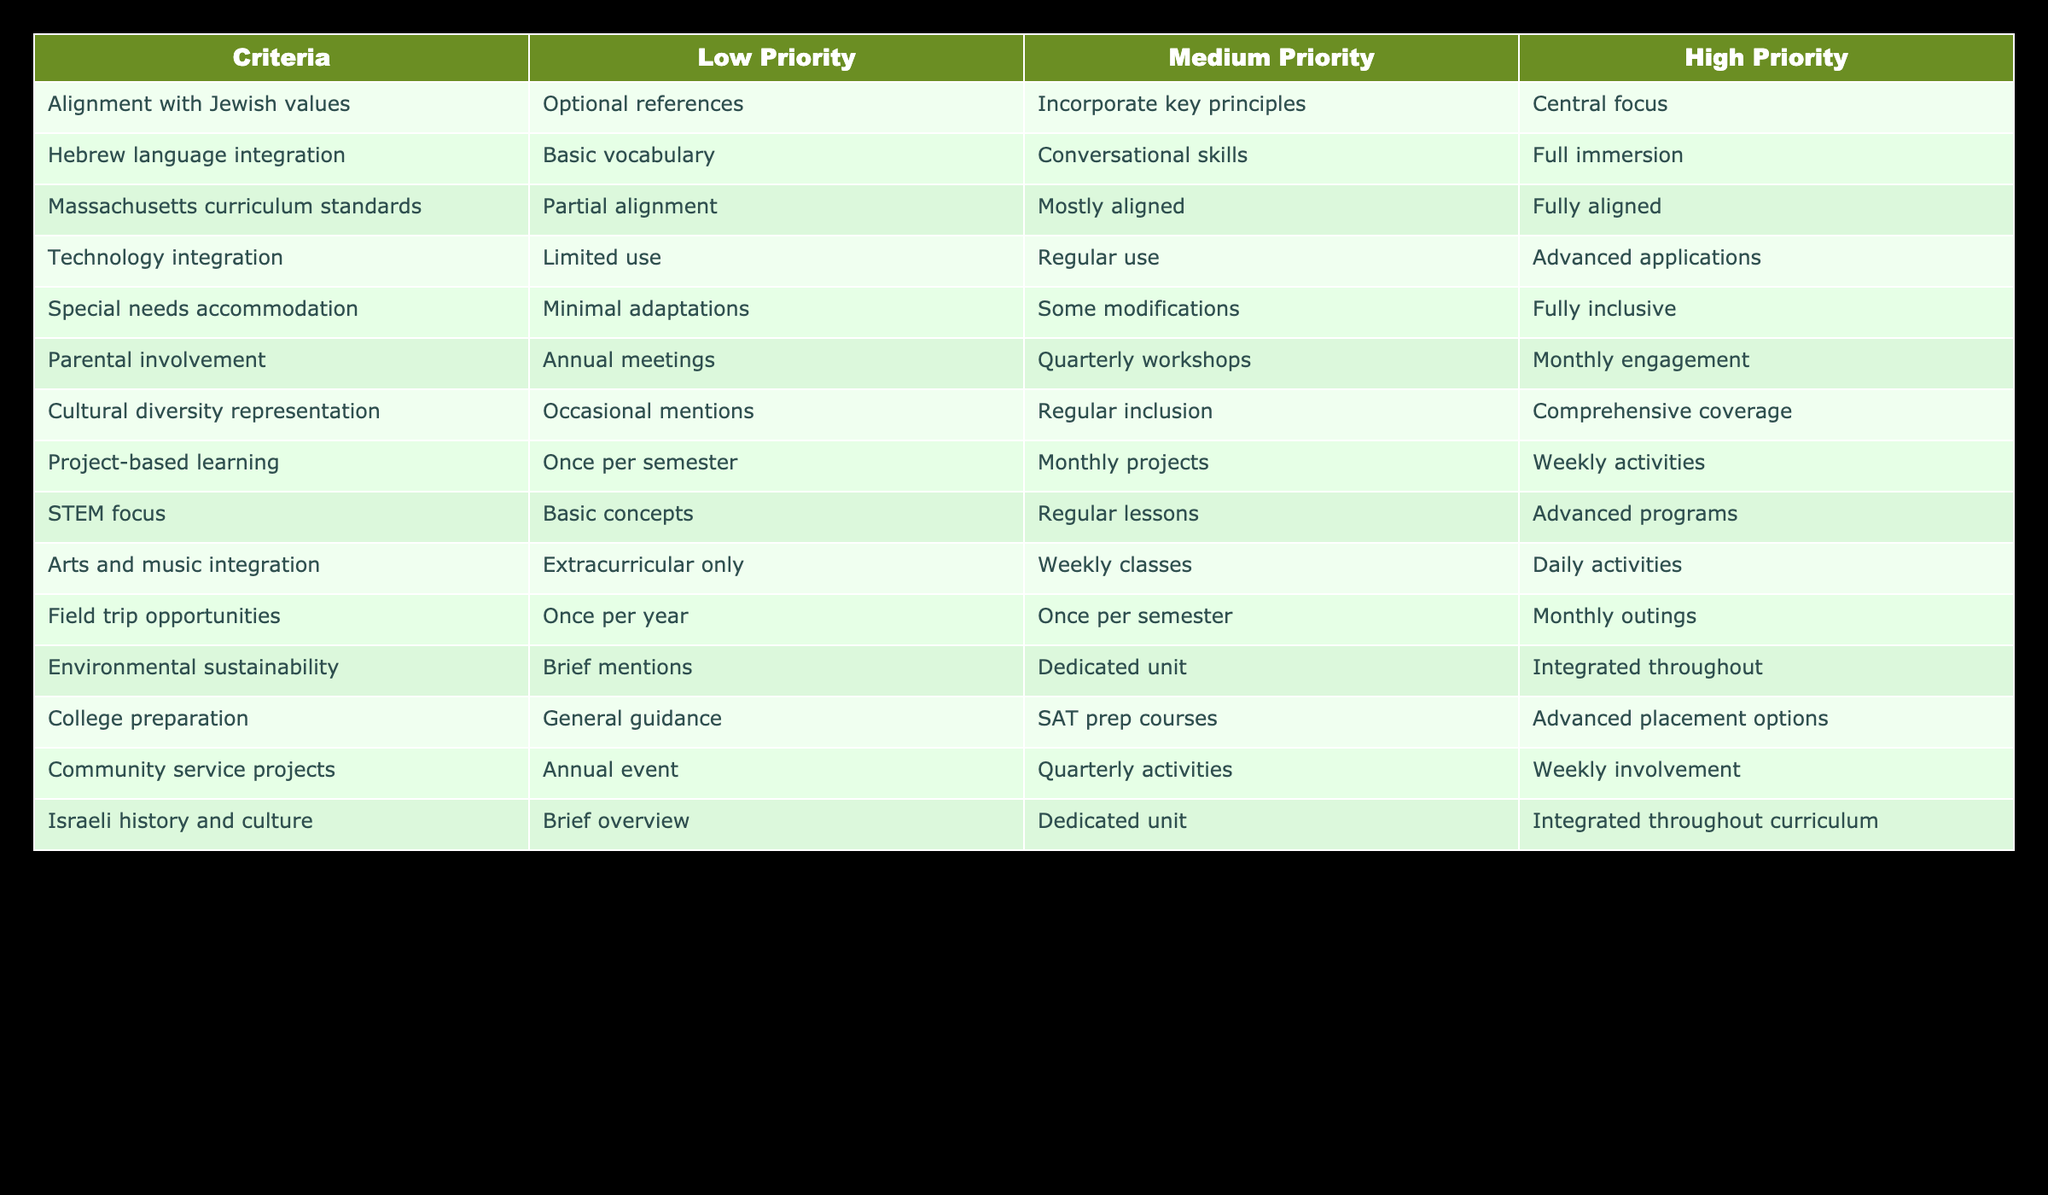What is the priority level for "Parental involvement"? The table indicates "Monthly engagement" under the High Priority column for Parental involvement, which represents the highest priority for this criterion.
Answer: High Priority How many criteria have "Full immersion" as a high priority? By examining the High Priority column, the criteria that list "Full immersion" are Hebrew language integration, Special needs accommodation, and Arts and music integration. Thus, there are three criteria that fall into this category.
Answer: 3 Is "College preparation" considered a low priority in the curriculum? The table shows "General guidance" under the Low Priority column for College preparation, which indicates that it is indeed considered a low priority.
Answer: Yes What is the highest priority focus for "Hebrew language integration"? The high priority for Hebrew language integration is listed as "Full immersion," signifying that the most emphasis should be placed on complete integration of the language into the curriculum.
Answer: Full immersion How does the priority for "Field trip opportunities" compare between mediums and high priorities? The table shows "Once per semester" under Medium Priority and "Monthly outings" under High Priority, suggesting that transitioning from medium to high priority greatly increases the frequency of field trip opportunities.
Answer: Increased frequency What is the average priority for "Cultural diversity representation" and "Project-based learning"? The Medium Priority for Cultural diversity representation is "Regular inclusion" and for Project-based learning it is "Monthly projects." This averages the priority levels, being defined by regular inclusion and projects happening monthly, resulting in a consistent approach to both.
Answer: Medium Priority Is there a high priority for "Environmental sustainability" in the curriculum? The table indicates "Integrated throughout" as the High Priority for Environmental sustainability, which means it has a strong focus and is therefore a high priority in the curriculum.
Answer: Yes Which criterion has the least priority in the context of technology integration? The Low Priority entry for technology integration is "Limited use," making it the criterion with the least priority regarding technological incorporation in the curriculum.
Answer: Limited use 